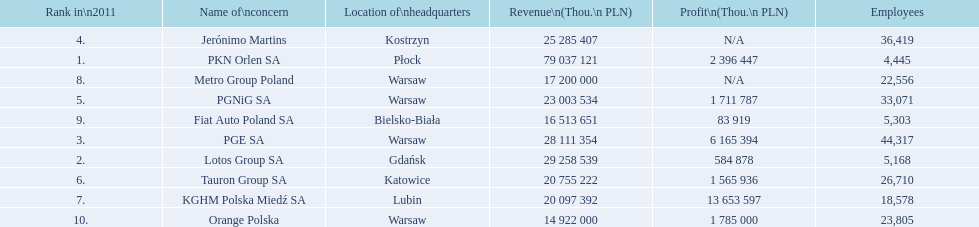Can you give me this table in json format? {'header': ['Rank in\\n2011', 'Name of\\nconcern', 'Location of\\nheadquarters', 'Revenue\\n(Thou.\\n\xa0PLN)', 'Profit\\n(Thou.\\n\xa0PLN)', 'Employees'], 'rows': [['4.', 'Jerónimo Martins', 'Kostrzyn', '25 285 407', 'N/A', '36,419'], ['1.', 'PKN Orlen SA', 'Płock', '79 037 121', '2 396 447', '4,445'], ['8.', 'Metro Group Poland', 'Warsaw', '17 200 000', 'N/A', '22,556'], ['5.', 'PGNiG SA', 'Warsaw', '23 003 534', '1 711 787', '33,071'], ['9.', 'Fiat Auto Poland SA', 'Bielsko-Biała', '16 513 651', '83 919', '5,303'], ['3.', 'PGE SA', 'Warsaw', '28 111 354', '6 165 394', '44,317'], ['2.', 'Lotos Group SA', 'Gdańsk', '29 258 539', '584 878', '5,168'], ['6.', 'Tauron Group SA', 'Katowice', '20 755 222', '1 565 936', '26,710'], ['7.', 'KGHM Polska Miedź SA', 'Lubin', '20 097 392', '13 653 597', '18,578'], ['10.', 'Orange Polska', 'Warsaw', '14 922 000', '1 785 000', '23,805']]} Which concern's headquarters are located in warsaw? PGE SA, PGNiG SA, Metro Group Poland. Which of these listed a profit? PGE SA, PGNiG SA. Of these how many employees are in the concern with the lowest profit? 33,071. 